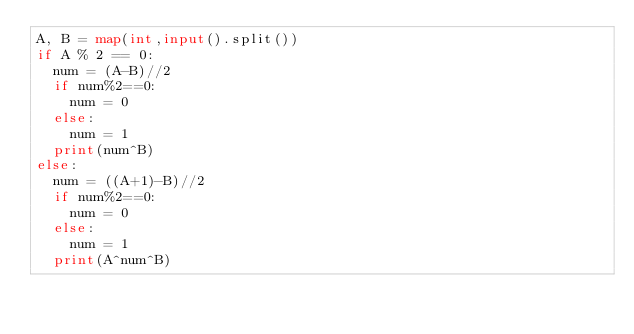<code> <loc_0><loc_0><loc_500><loc_500><_Python_>A, B = map(int,input().split())
if A % 2 == 0:
  num = (A-B)//2
  if num%2==0:
    num = 0
  else:
    num = 1
  print(num^B)
else:
  num = ((A+1)-B)//2
  if num%2==0:
    num = 0
  else:
    num = 1
  print(A^num^B)</code> 